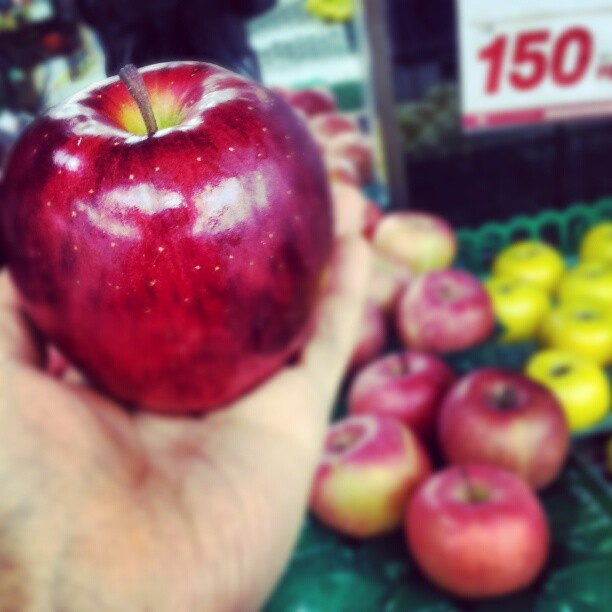Describe the objects in this image and their specific colors. I can see apple in navy, brown, maroon, and purple tones, people in navy, tan, and beige tones, apple in navy, salmon, and brown tones, apple in navy, brown, tan, and maroon tones, and apple in navy, lightpink, brown, violet, and khaki tones in this image. 